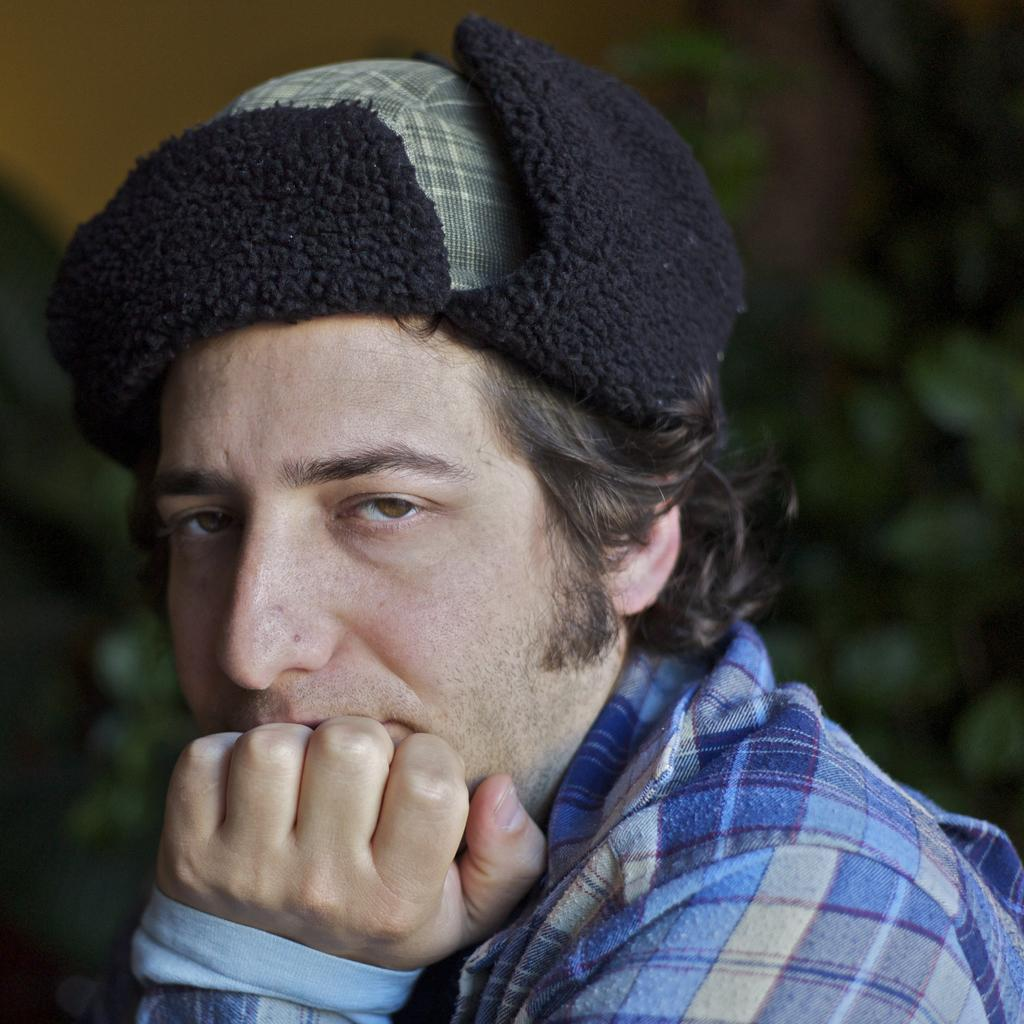What is the main subject of the image? There is a person in the image. What is the person wearing on their head? The person is wearing a cap. What type of clothing is the person wearing on their body? The person is wearing a dress. What type of wine is the person holding in the image? There is no wine present in the image; the person is not holding any wine. 